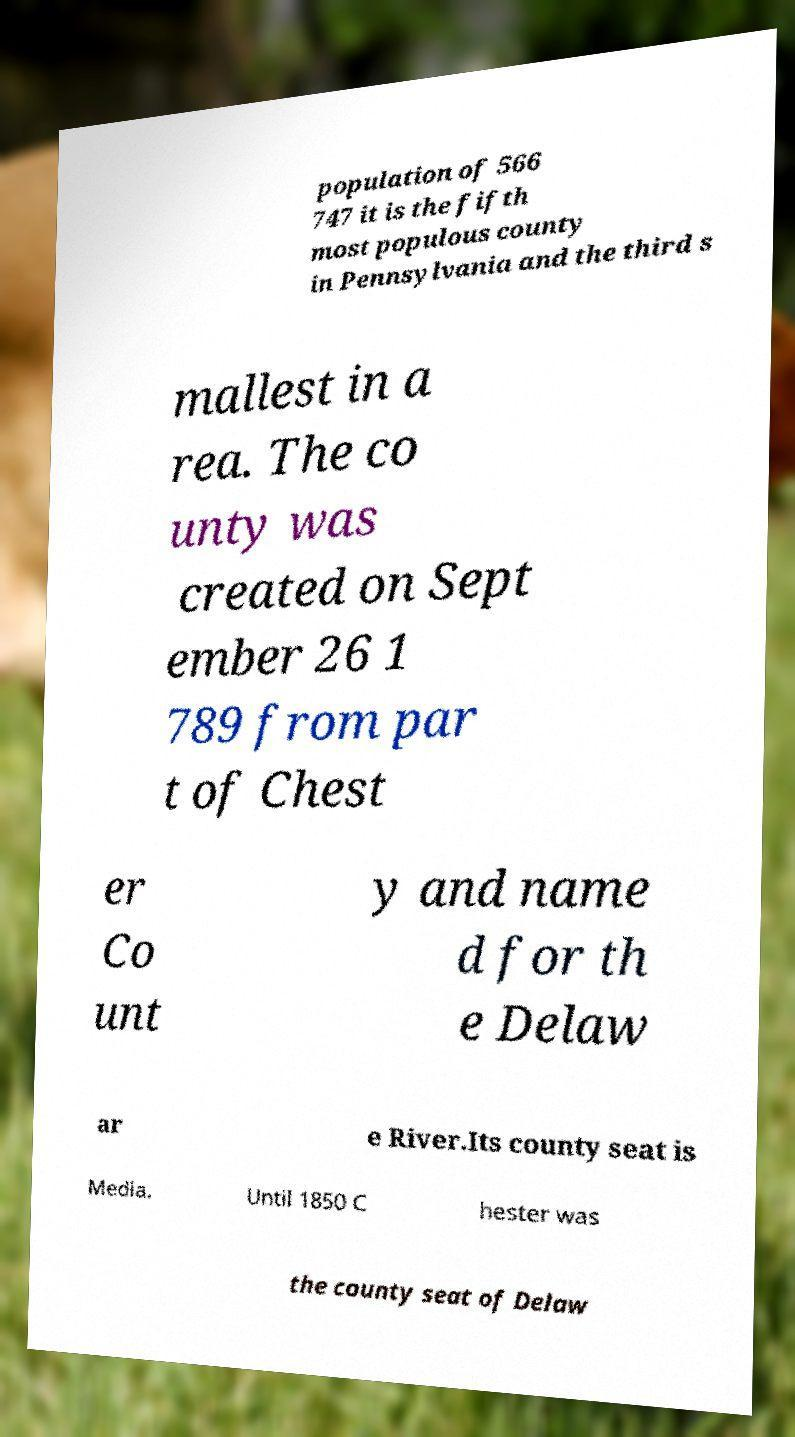I need the written content from this picture converted into text. Can you do that? population of 566 747 it is the fifth most populous county in Pennsylvania and the third s mallest in a rea. The co unty was created on Sept ember 26 1 789 from par t of Chest er Co unt y and name d for th e Delaw ar e River.Its county seat is Media. Until 1850 C hester was the county seat of Delaw 